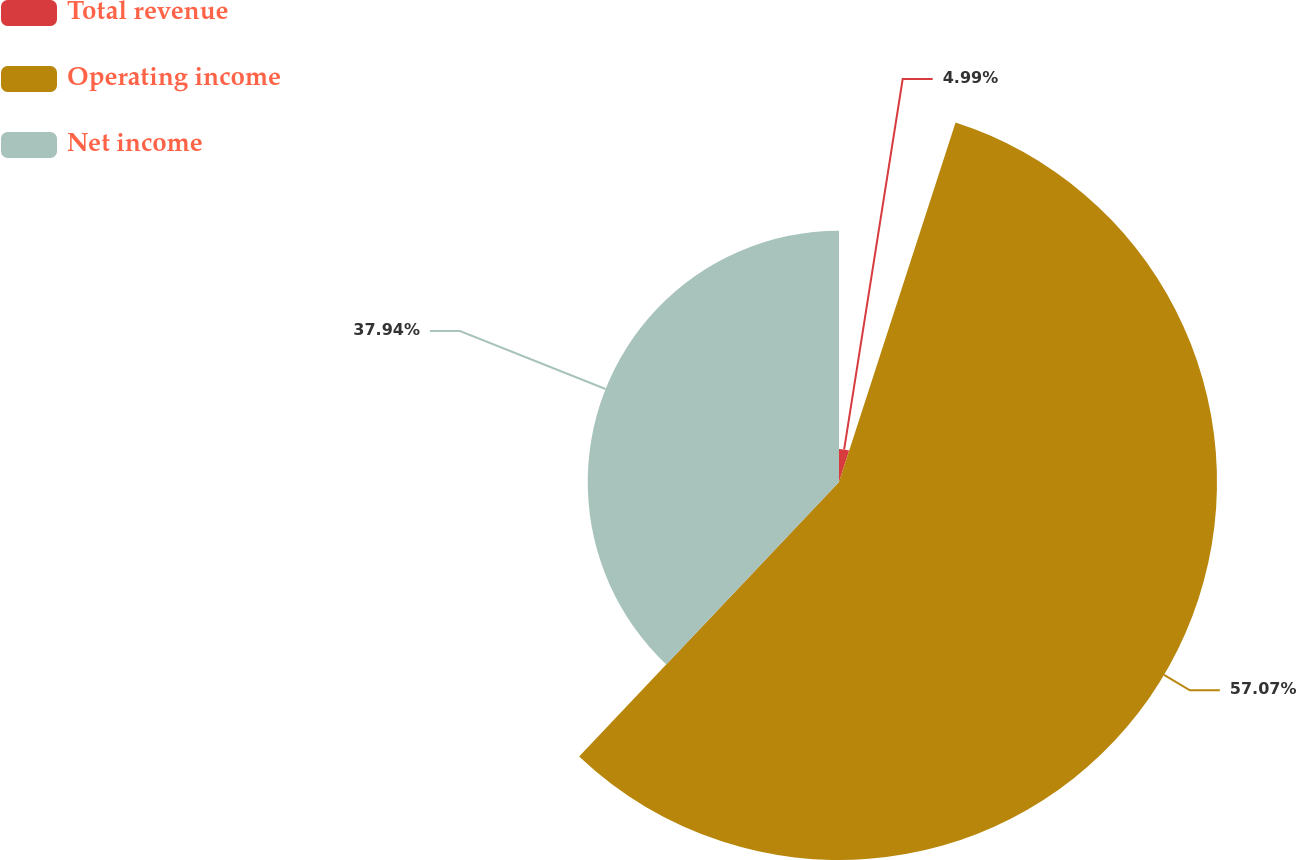Convert chart to OTSL. <chart><loc_0><loc_0><loc_500><loc_500><pie_chart><fcel>Total revenue<fcel>Operating income<fcel>Net income<nl><fcel>4.99%<fcel>57.08%<fcel>37.94%<nl></chart> 